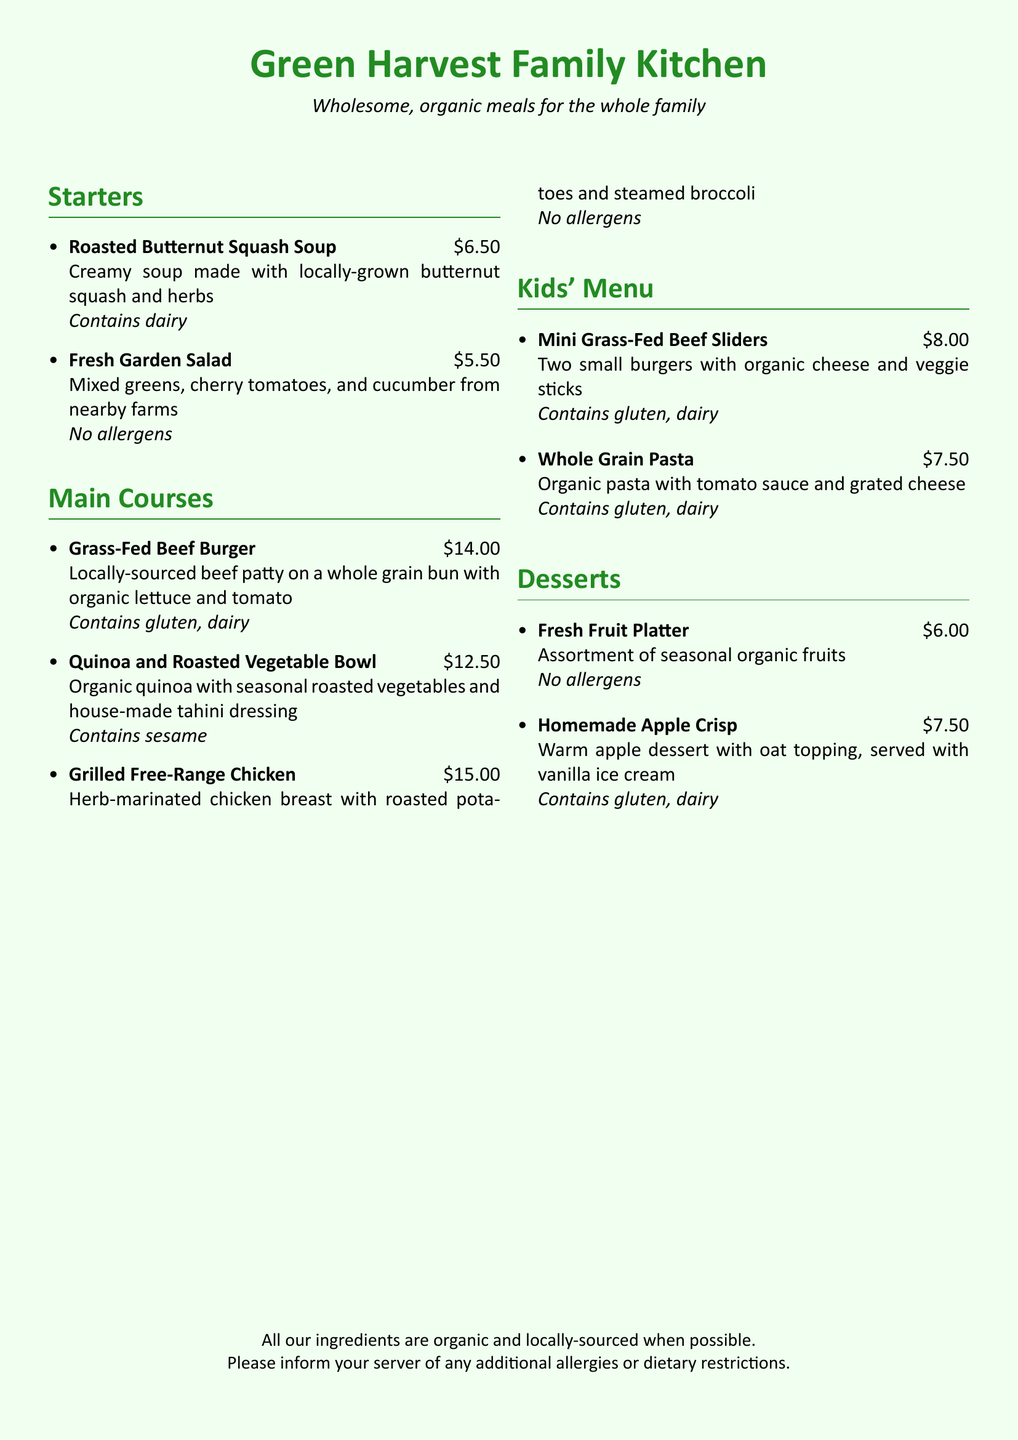What is the price of the Roasted Butternut Squash Soup? The price is listed directly next to the dish description in the menu.
Answer: $6.50 What allergens are in the Grass-Fed Beef Burger? The allergens are listed at the end of the dish's description.
Answer: Contains gluten, dairy How many mini sliders are in the Kids' Menu item? The quantity is mentioned in the description of the Mini Grass-Fed Beef Sliders.
Answer: Two What is the total number of dishes on the Kids' Menu? The number of items can be counted from the Kids' Menu section in the document.
Answer: Two What vegetable accompanies the Grilled Free-Range Chicken? The specific side vegetable is indicated in the dish description.
Answer: Steamed broccoli Which dessert does not contain allergens? The allergen information allows us to identify desserts without any allergens.
Answer: Fresh Fruit Platter What type of cheese is used in the Mini Grass-Fed Beef Sliders? The type of cheese is specified in the description of the dish.
Answer: Organic cheese How much does the quinoa bowl cost? The price is provided next to the dish name in the menu.
Answer: $12.50 Which dish contains sesame? The allergen information specifies the dish with sesame in its description.
Answer: Quinoa and Roasted Vegetable Bowl 